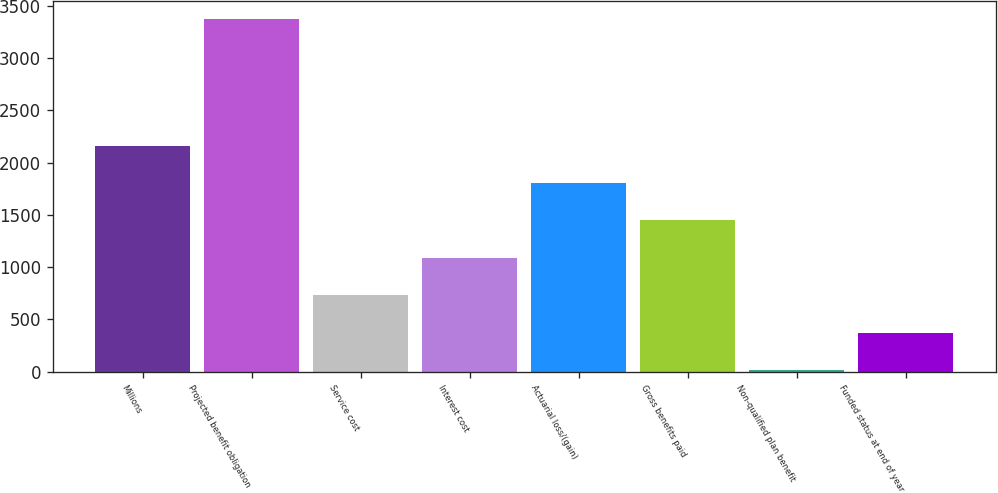Convert chart to OTSL. <chart><loc_0><loc_0><loc_500><loc_500><bar_chart><fcel>Millions<fcel>Projected benefit obligation<fcel>Service cost<fcel>Interest cost<fcel>Actuarial loss/(gain)<fcel>Gross benefits paid<fcel>Non-qualified plan benefit<fcel>Funded status at end of year<nl><fcel>2161<fcel>3372<fcel>731<fcel>1088.5<fcel>1803.5<fcel>1446<fcel>16<fcel>373.5<nl></chart> 